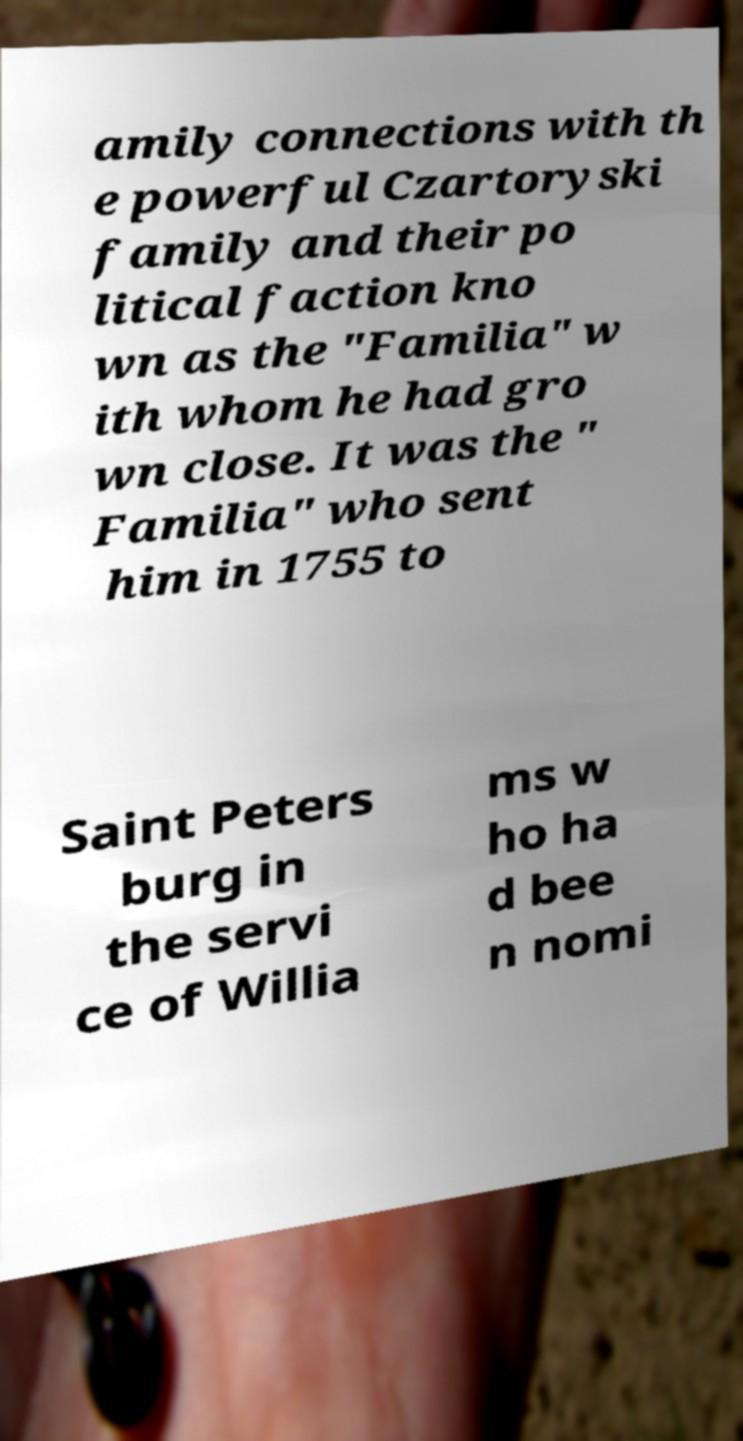Can you accurately transcribe the text from the provided image for me? amily connections with th e powerful Czartoryski family and their po litical faction kno wn as the "Familia" w ith whom he had gro wn close. It was the " Familia" who sent him in 1755 to Saint Peters burg in the servi ce of Willia ms w ho ha d bee n nomi 